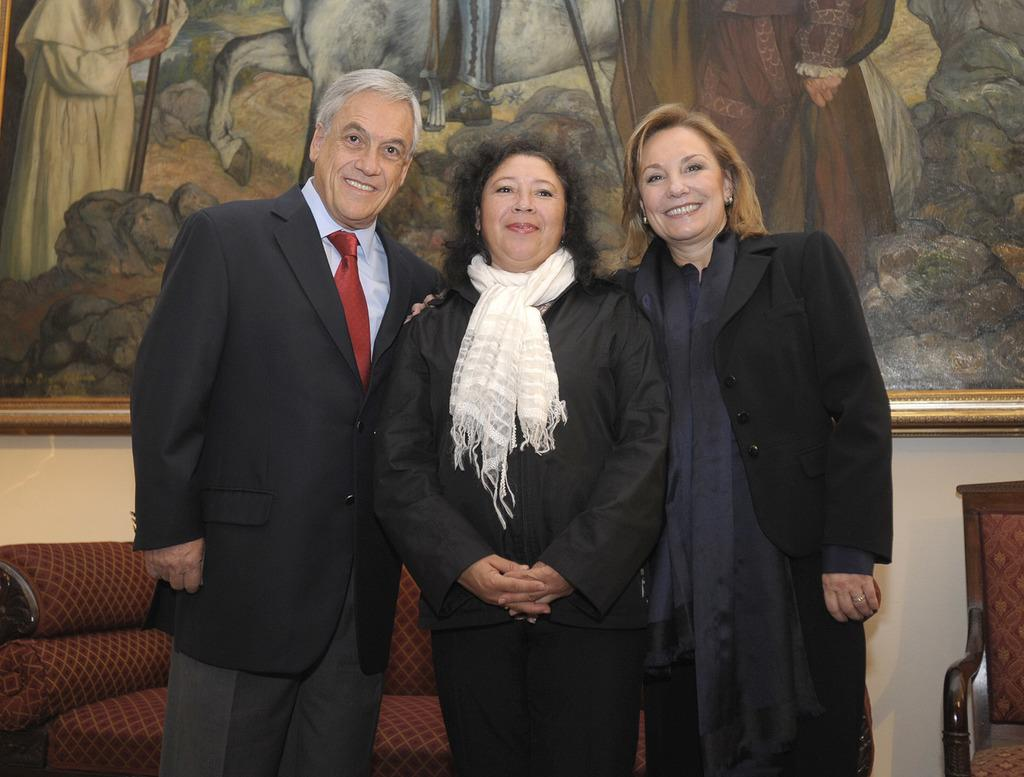How many people are present in the image? There are three people standing in the image. What can be seen on the wall in the image? There is a photo frame on the wall. What type of furniture is visible on the ground in the image? Chairs are visible on the ground in the image. What type of shoes are the people wearing in the image? There is no information about shoes in the image, as the focus is on the people standing and the objects around them. 